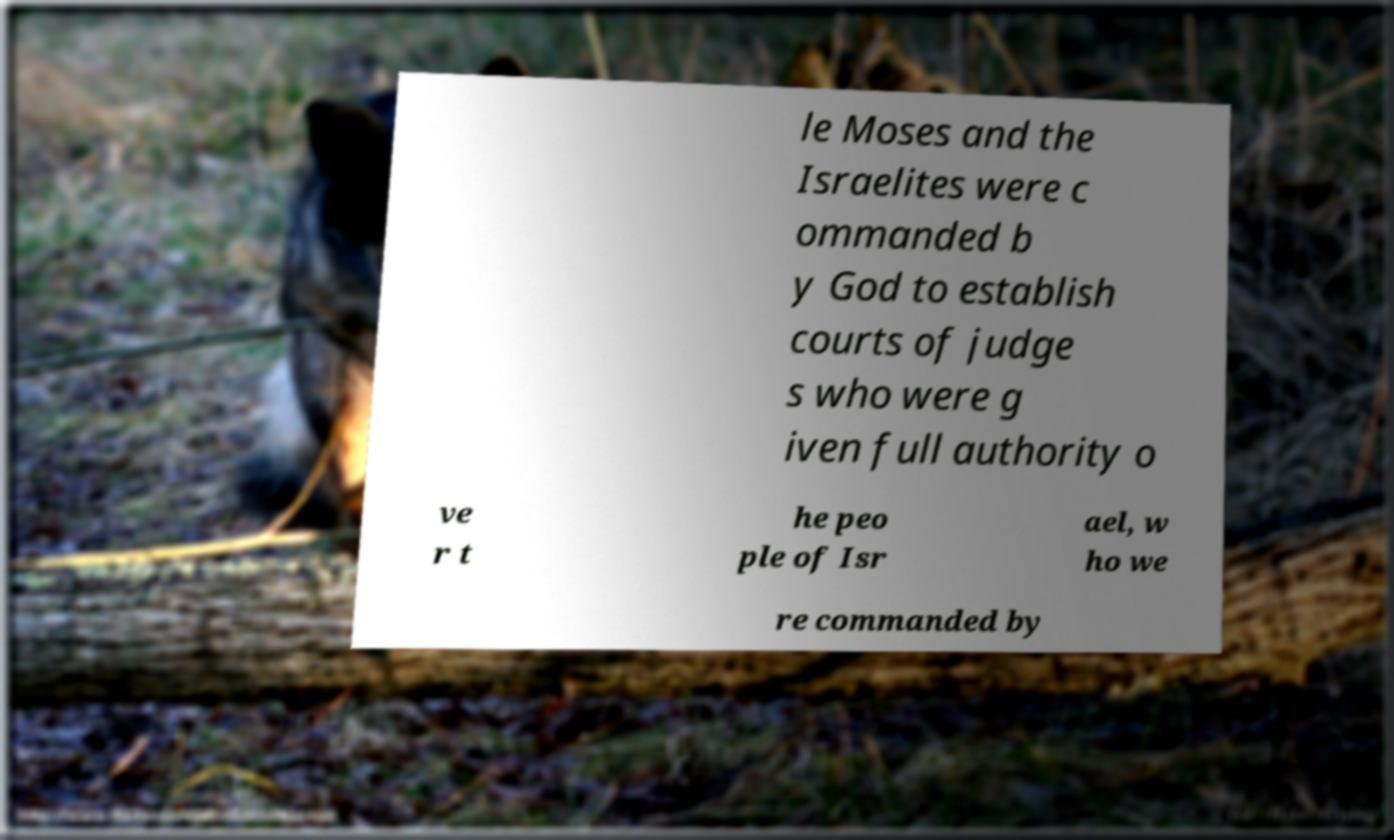Can you accurately transcribe the text from the provided image for me? le Moses and the Israelites were c ommanded b y God to establish courts of judge s who were g iven full authority o ve r t he peo ple of Isr ael, w ho we re commanded by 